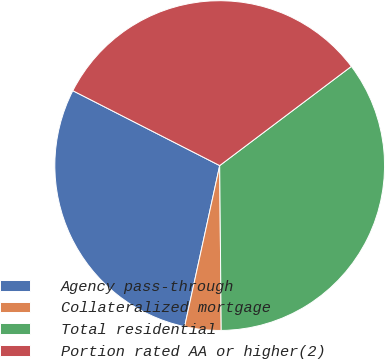<chart> <loc_0><loc_0><loc_500><loc_500><pie_chart><fcel>Agency pass-through<fcel>Collateralized mortgage<fcel>Total residential<fcel>Portion rated AA or higher(2)<nl><fcel>29.09%<fcel>3.56%<fcel>35.13%<fcel>32.22%<nl></chart> 